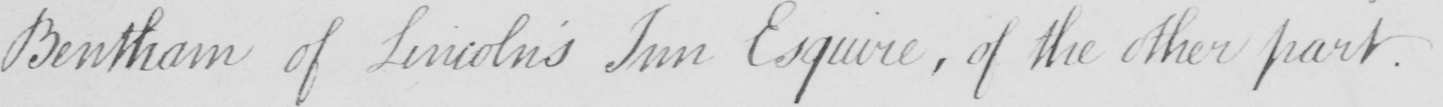Can you tell me what this handwritten text says? Bentham of Lincoln ' s Inn Esquire  , of the other part . 